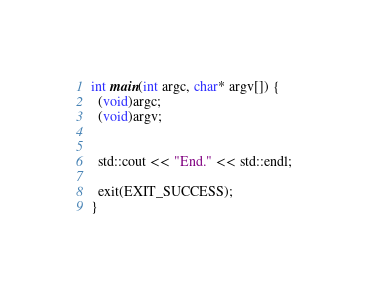<code> <loc_0><loc_0><loc_500><loc_500><_C++_>
int main(int argc, char* argv[]) {
  (void)argc;
  (void)argv;


  std::cout << "End." << std::endl;

  exit(EXIT_SUCCESS);
}
</code> 